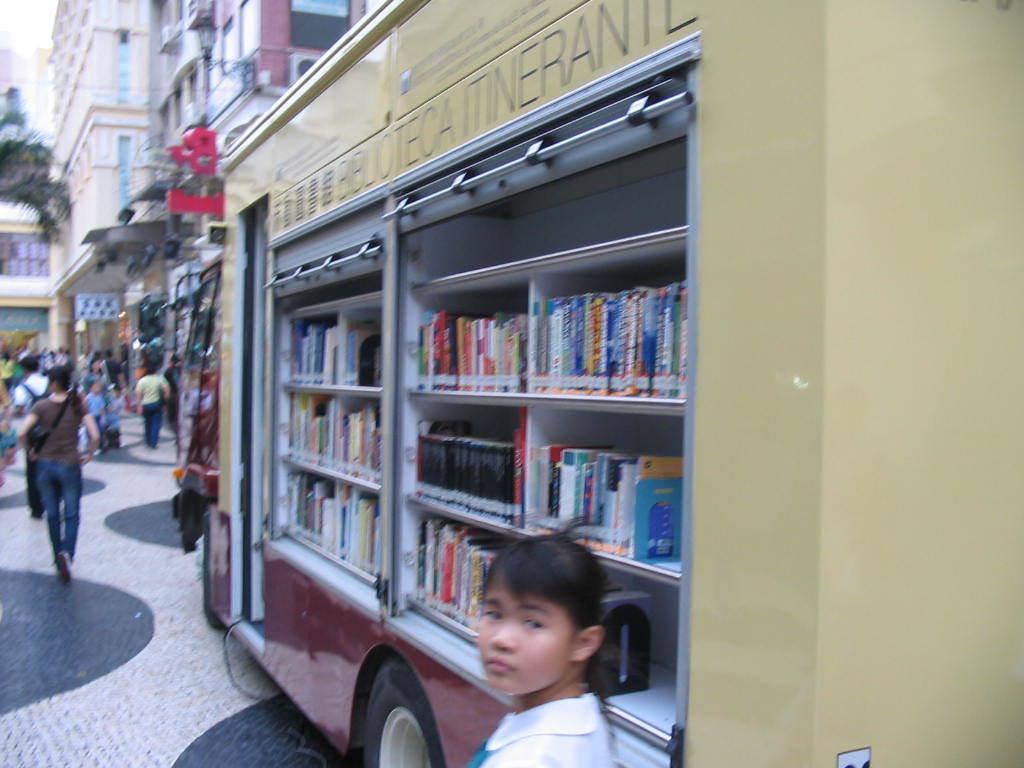Can you describe this image briefly? In this image there are a few books arranged in a vehicle, in front of the vehicle there are a few people walking on the road, beside the vehicle there is a lady standing. In the background there are buildings and trees. 